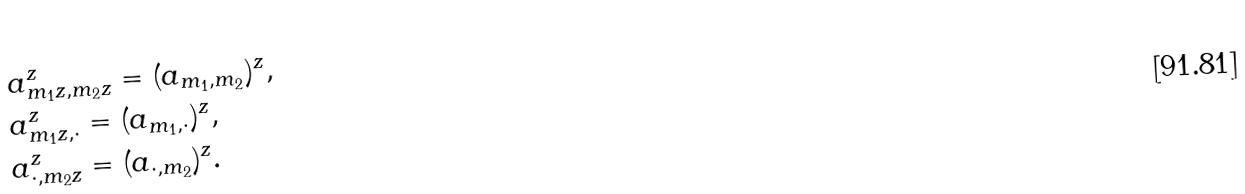<formula> <loc_0><loc_0><loc_500><loc_500>& a ^ { z } _ { m _ { 1 } z , m _ { 2 } z } = ( a _ { m _ { 1 } , m _ { 2 } } ) ^ { z } , \\ & a ^ { z } _ { m _ { 1 } z , \cdot } = ( a _ { m _ { 1 } , \cdot } ) ^ { z } , \\ & a ^ { z } _ { \cdot , m _ { 2 } z } = ( a _ { \cdot , m _ { 2 } } ) ^ { z } . \\</formula> 